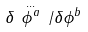<formula> <loc_0><loc_0><loc_500><loc_500>\delta \, \stackrel { \dots } { \phi ^ { a } } \, / \delta \phi ^ { b }</formula> 